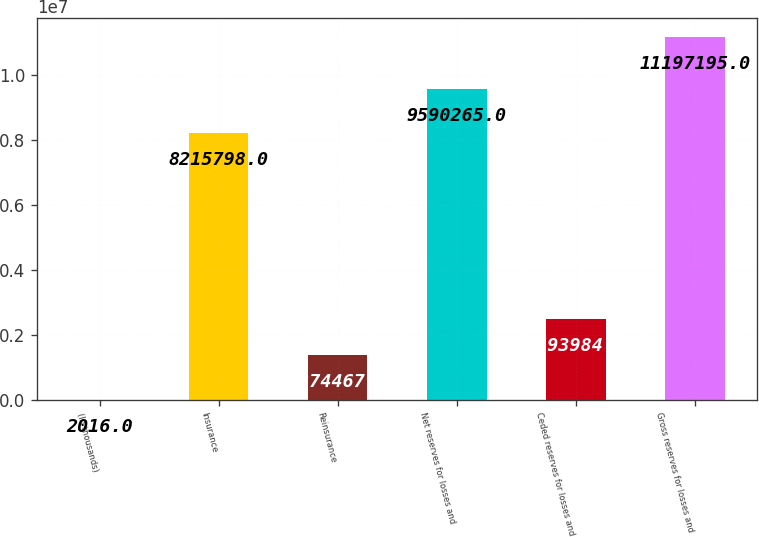<chart> <loc_0><loc_0><loc_500><loc_500><bar_chart><fcel>(In thousands)<fcel>Insurance<fcel>Reinsurance<fcel>Net reserves for losses and<fcel>Ceded reserves for losses and<fcel>Gross reserves for losses and<nl><fcel>2016<fcel>8.2158e+06<fcel>1.37447e+06<fcel>9.59026e+06<fcel>2.49398e+06<fcel>1.11972e+07<nl></chart> 